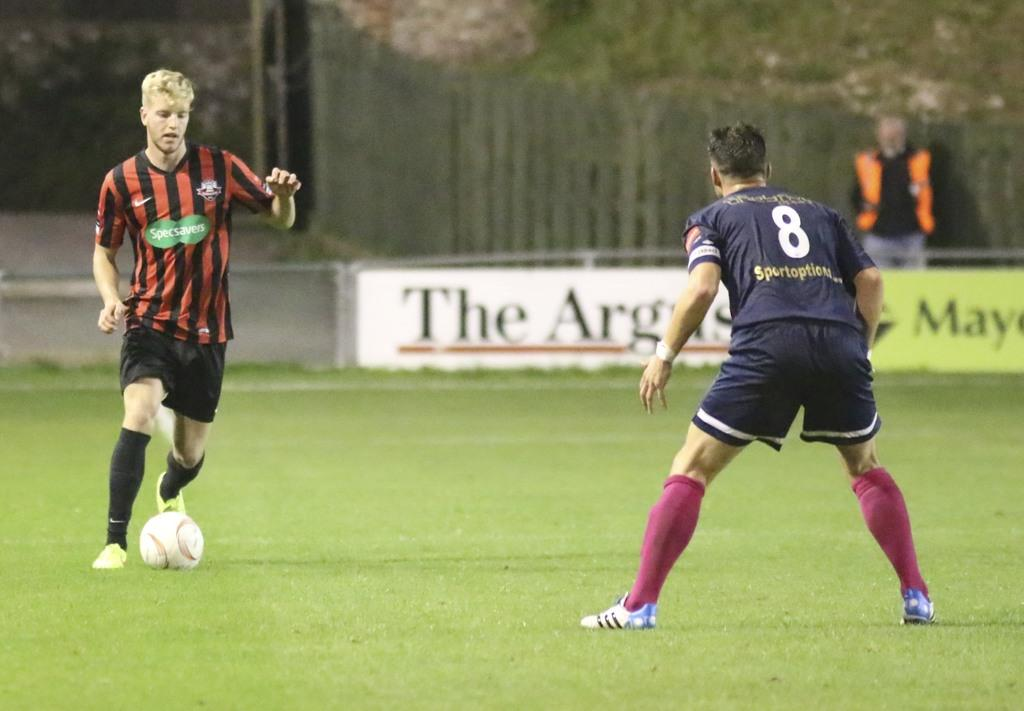<image>
Offer a succinct explanation of the picture presented. Two people playing soccer one has a striped specsavers jersey. 